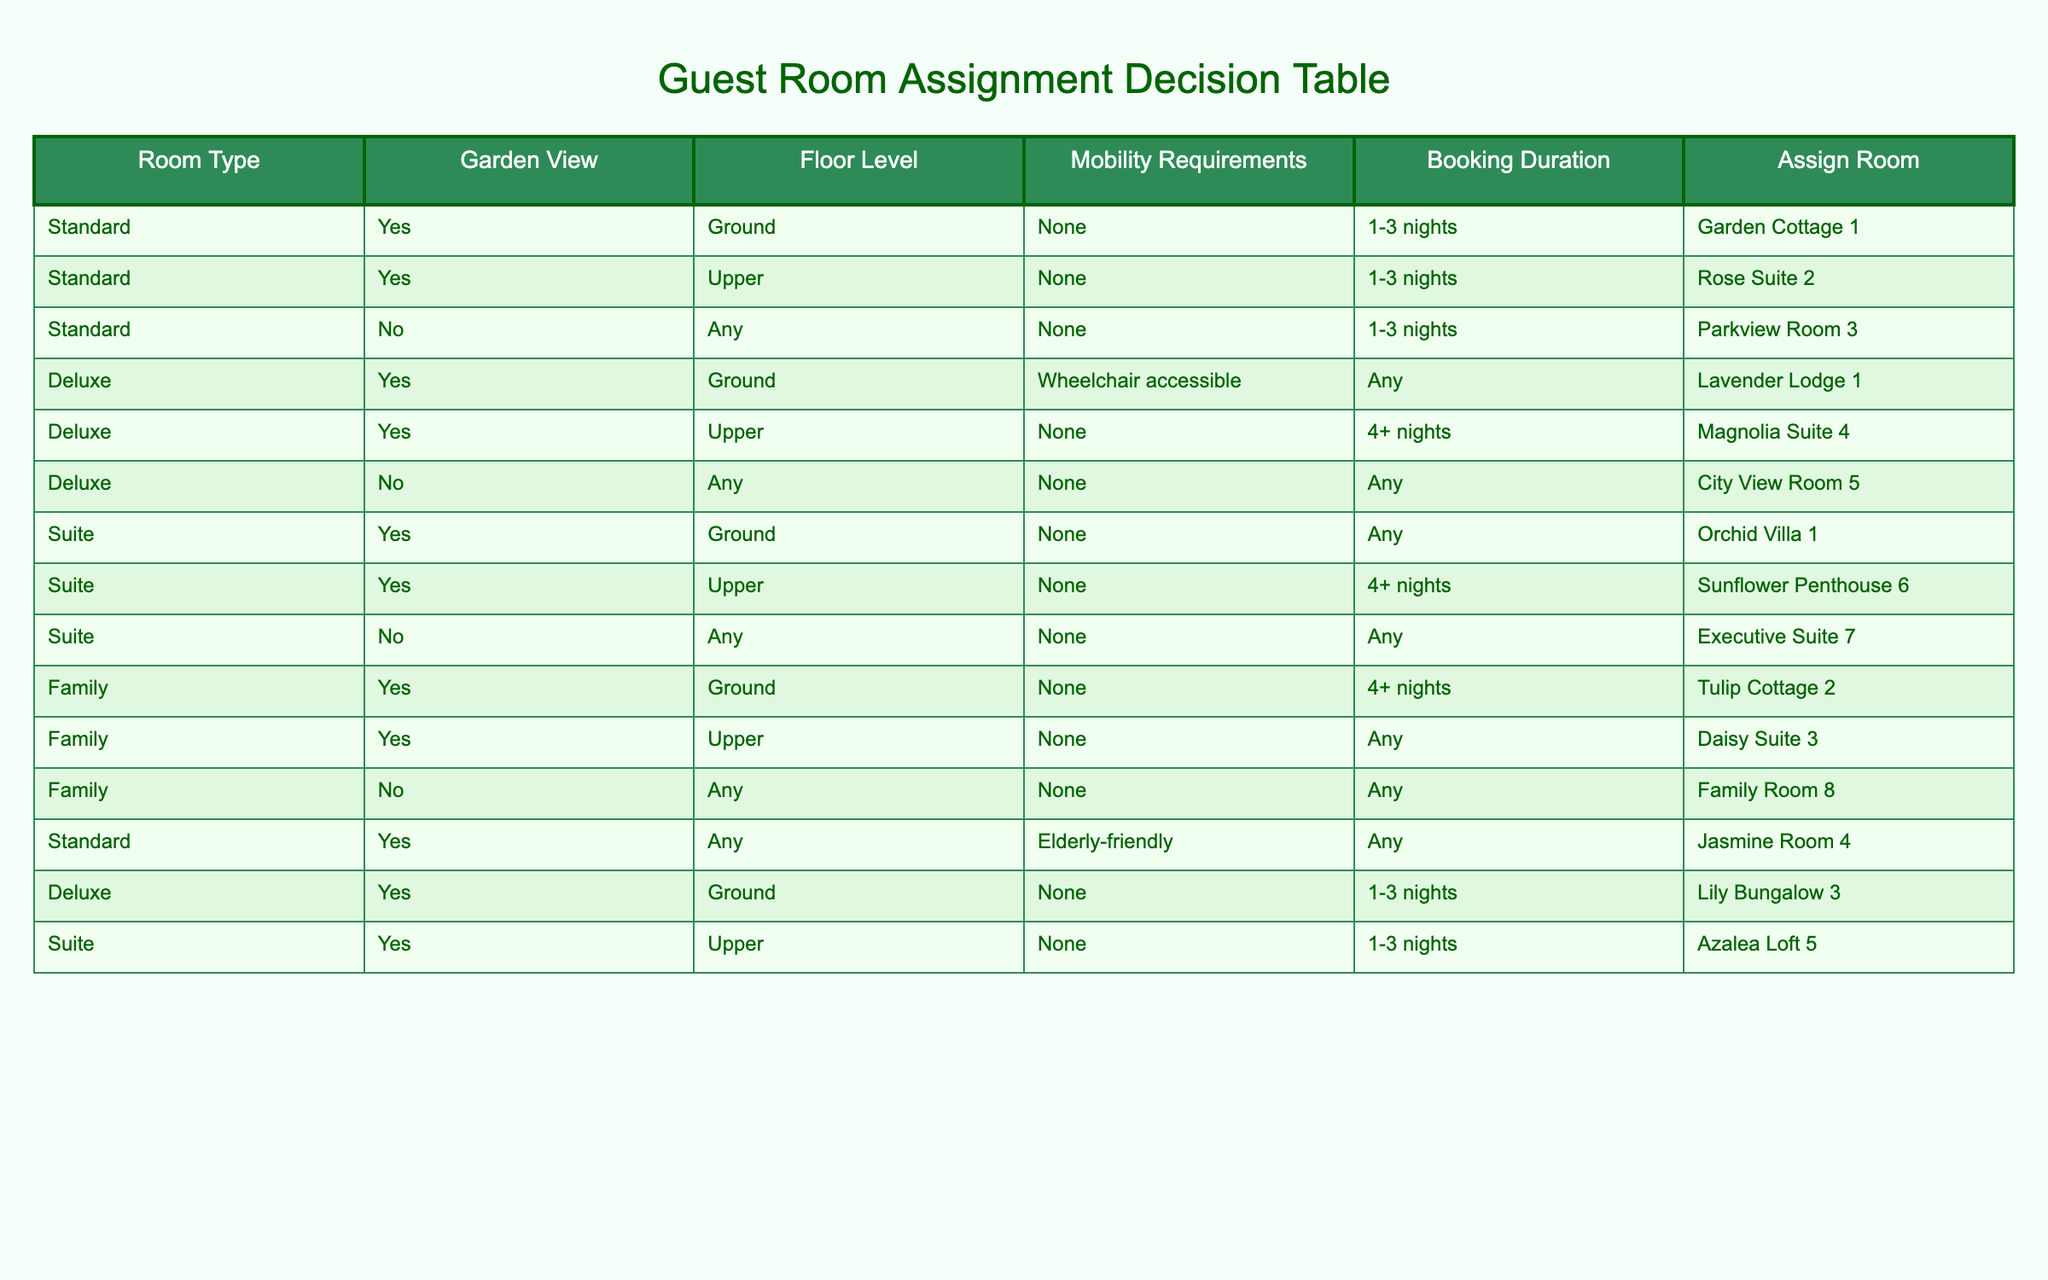What is the total number of garden view rooms assigned for bookings of 1-3 nights? There are three entries in the table for garden view rooms with booking durations of 1-3 nights: Garden Cottage 1, Rose Suite 2, and Lily Bungalow 3. Adding these gives a total of 3 garden view rooms.
Answer: 3 Are there any family rooms with a garden view assigned for bookings longer than 4 nights? The table shows that the only family room assigned is Family Room 8, which does not have a garden view. Therefore, there are no family rooms with garden view assigned for bookings longer than 4 nights.
Answer: No Which Deluxe room has a garden view and is suitable for wheelchair users? From the table, the only room that meets this criteria is Lavender Lodge 1, which is a ground floor Deluxe room with a garden view that is also wheelchair accessible.
Answer: Lavender Lodge 1 What is the maximum number of nights recommended for booking a Standard room with a garden view? The table indicates that Standard rooms with a garden view are assigned for bookings of up to 3 nights only (Garden Cottage 1 and Rose Suite 2). The maximum number of nights is therefore 3.
Answer: 3 If a guest needs a room on the ground floor, which Suite and Deluxe rooms can they be assigned? The table lists Orchid Villa 1 and Lavender Lodge 1 as suitable rooms on the ground floor. Both of these rooms are in the Suite and Deluxe categories respectively.
Answer: Orchid Villa 1, Lavender Lodge 1 How many rooms in total can accommodate elderly-friendly mobility requirements? In the table, there are two entries for elderly-friendly mobility requirements: Jasmine Room 4 (Standard), and none in the Deluxe and Suite categories. Thus, there is a total of 1 room accommodating elderly-friendly requirements.
Answer: 1 Is it possible for a guest to book a Standard room for 4 or more nights with a garden view? The table shows that all Standard rooms with garden views are assigned for 1-3 nights only. Therefore, it is not possible to book a Standard room for 4 or more nights with a garden view.
Answer: No Which family rooms have been assigned and can accommodate any mobility requirements? There are two family rooms: Daisy Suite 3 and Family Room 8, both of which do not specify any mobility requirements. Thus, they can accommodate guests with any mobility requirements.
Answer: Daisy Suite 3, Family Room 8 What is the room assignment for a Deluxe room without a garden view, and what are its features? The table indicates that the City View Room 5 is assigned as a Deluxe room without a garden view. This room can be assigned for any booking duration, as it has no specific mobility requirements.
Answer: City View Room 5 